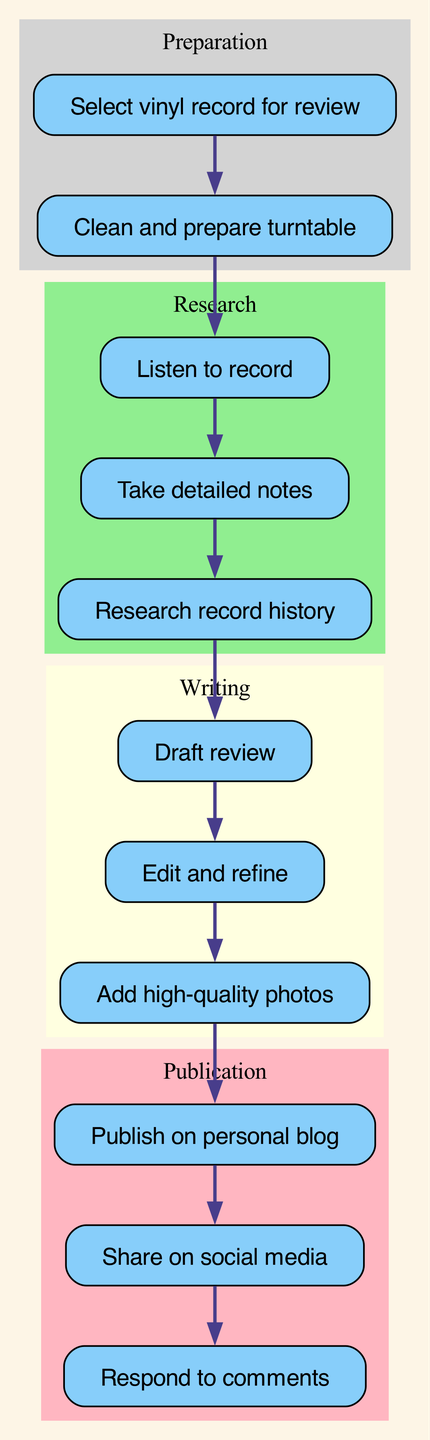What is the total number of nodes in the diagram? By counting the distinct steps listed in the diagram, we find there are ten unique nodes representing different stages in the workflow.
Answer: 10 What is the first step in the workflow? The first node in the diagram clearly indicates that the process begins with selecting a vinyl record for review.
Answer: Select vinyl record for review Which node comes after "Listen to record"? Looking at the edges, the diagram shows that after "Listen to record," the next step is "Take detailed notes."
Answer: Take detailed notes How many edges are represented in the diagram? Counting the connections (or edges) that connect the nodes illustrates that there are ten edges in total throughout the workflow.
Answer: 10 What stage includes the nodes "Draft review," "Edit and refine," and "Add high-quality photos"? Observing the clusters, it is clear that these nodes are part of the "Writing" stage, which groups all writing-related activities.
Answer: Writing What is the final step of the workflow? The diagram indicates that the last node, which follows "Share on social media," is "Respond to comments," making it the concluding step of the process.
Answer: Respond to comments Which two nodes form a direct connection without any intervening steps? By analyzing the edges, "Draft review" and "Edit and refine" are connected directly, indicating a seamless transition between these two steps.
Answer: Draft review, Edit and refine Which cluster identifies the preparation activities? Reviewing the subgraphs in the diagram, the cluster labeled "Preparation" clearly contains the activities related to getting ready for the review process.
Answer: Preparation What historically follows the completion of "Add high-quality photos"? The visual representation shows that "Add high-quality photos" directly leads into "Publish on personal blog," showing the sequence of actions taken.
Answer: Publish on personal blog 